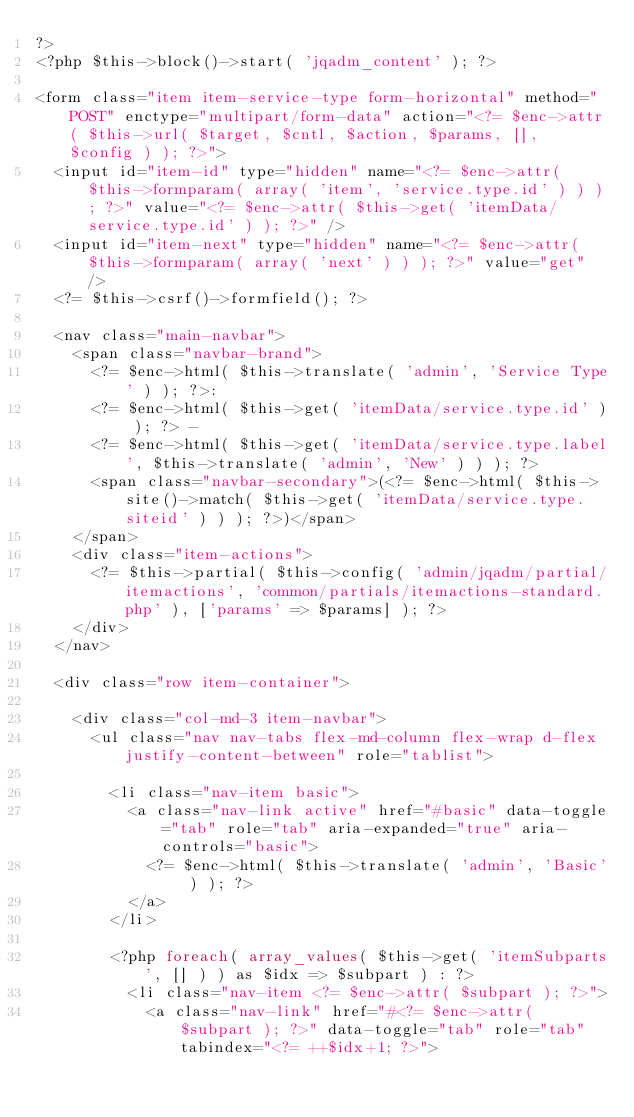<code> <loc_0><loc_0><loc_500><loc_500><_PHP_>?>
<?php $this->block()->start( 'jqadm_content' ); ?>

<form class="item item-service-type form-horizontal" method="POST" enctype="multipart/form-data" action="<?= $enc->attr( $this->url( $target, $cntl, $action, $params, [], $config ) ); ?>">
	<input id="item-id" type="hidden" name="<?= $enc->attr( $this->formparam( array( 'item', 'service.type.id' ) ) ); ?>" value="<?= $enc->attr( $this->get( 'itemData/service.type.id' ) ); ?>" />
	<input id="item-next" type="hidden" name="<?= $enc->attr( $this->formparam( array( 'next' ) ) ); ?>" value="get" />
	<?= $this->csrf()->formfield(); ?>

	<nav class="main-navbar">
		<span class="navbar-brand">
			<?= $enc->html( $this->translate( 'admin', 'Service Type' ) ); ?>:
			<?= $enc->html( $this->get( 'itemData/service.type.id' ) ); ?> -
			<?= $enc->html( $this->get( 'itemData/service.type.label', $this->translate( 'admin', 'New' ) ) ); ?>
			<span class="navbar-secondary">(<?= $enc->html( $this->site()->match( $this->get( 'itemData/service.type.siteid' ) ) ); ?>)</span>
		</span>
		<div class="item-actions">
			<?= $this->partial( $this->config( 'admin/jqadm/partial/itemactions', 'common/partials/itemactions-standard.php' ), ['params' => $params] ); ?>
		</div>
	</nav>

	<div class="row item-container">

		<div class="col-md-3 item-navbar">
			<ul class="nav nav-tabs flex-md-column flex-wrap d-flex justify-content-between" role="tablist">

				<li class="nav-item basic">
					<a class="nav-link active" href="#basic" data-toggle="tab" role="tab" aria-expanded="true" aria-controls="basic">
						<?= $enc->html( $this->translate( 'admin', 'Basic' ) ); ?>
					</a>
				</li>

				<?php foreach( array_values( $this->get( 'itemSubparts', [] ) ) as $idx => $subpart ) : ?>
					<li class="nav-item <?= $enc->attr( $subpart ); ?>">
						<a class="nav-link" href="#<?= $enc->attr( $subpart ); ?>" data-toggle="tab" role="tab" tabindex="<?= ++$idx+1; ?>"></code> 